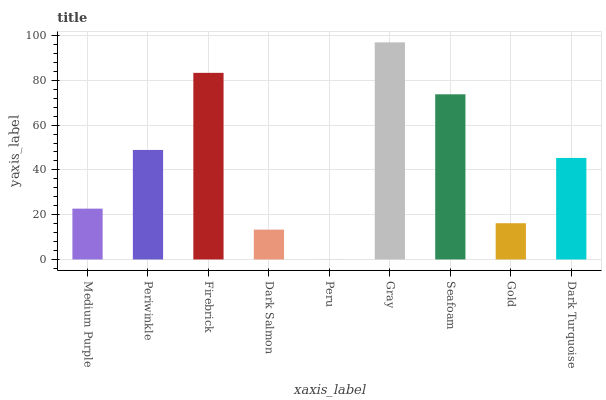Is Peru the minimum?
Answer yes or no. Yes. Is Gray the maximum?
Answer yes or no. Yes. Is Periwinkle the minimum?
Answer yes or no. No. Is Periwinkle the maximum?
Answer yes or no. No. Is Periwinkle greater than Medium Purple?
Answer yes or no. Yes. Is Medium Purple less than Periwinkle?
Answer yes or no. Yes. Is Medium Purple greater than Periwinkle?
Answer yes or no. No. Is Periwinkle less than Medium Purple?
Answer yes or no. No. Is Dark Turquoise the high median?
Answer yes or no. Yes. Is Dark Turquoise the low median?
Answer yes or no. Yes. Is Dark Salmon the high median?
Answer yes or no. No. Is Dark Salmon the low median?
Answer yes or no. No. 